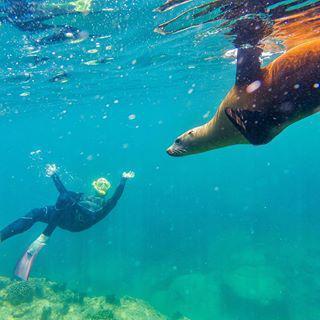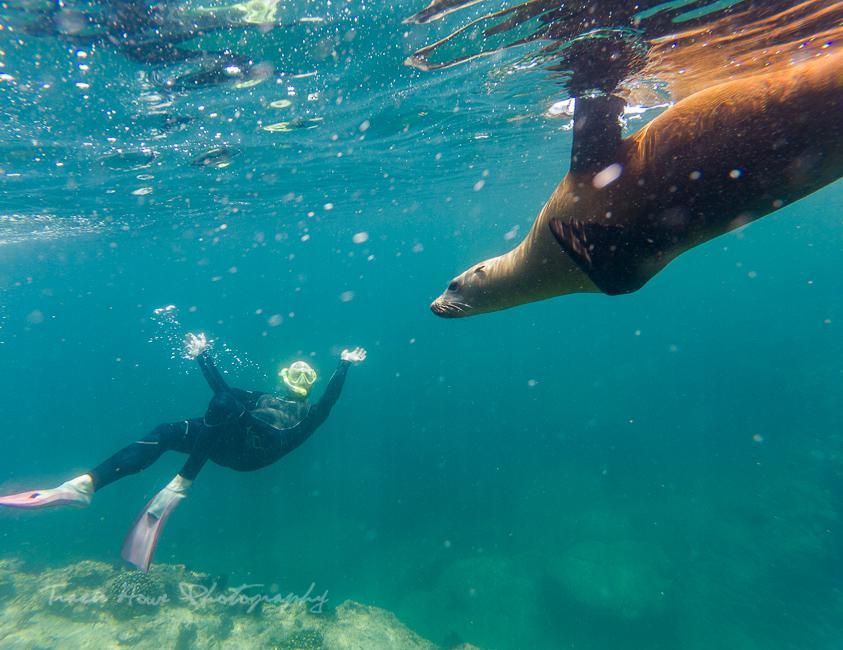The first image is the image on the left, the second image is the image on the right. Assess this claim about the two images: "there is a diver looking at a seal underwater". Correct or not? Answer yes or no. Yes. The first image is the image on the left, the second image is the image on the right. Assess this claim about the two images: "There is one person on the ocean floor.". Correct or not? Answer yes or no. No. 